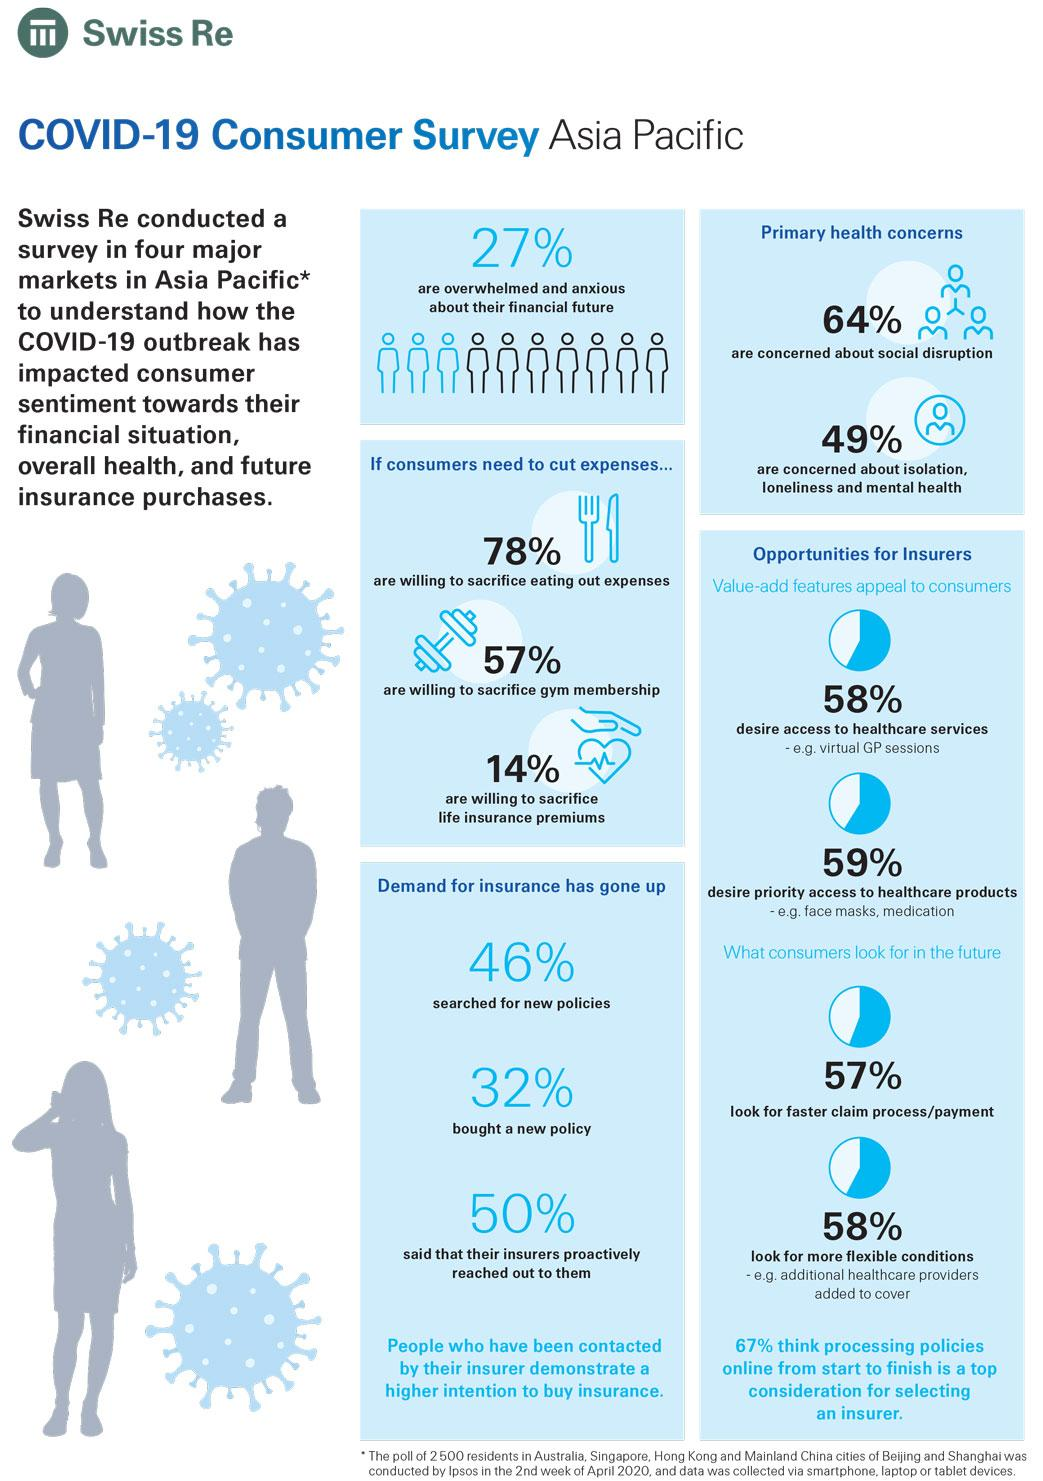Give some essential details in this illustration. According to the survey conducted in the Asia Pacific region, 36% of consumers are not concerned about social disruption. According to a survey conducted in the Asia Pacific region, 46% of consumers searched for new insurance policies. According to a recent survey conducted in the Asia Pacific region, 86% of consumers are unwilling to sacrifice life insurance premiums if they need to cut down on expenses. According to the survey conducted in the Asia Pacific region, 32% of consumers purchased a new policy. According to a survey conducted in the Asia Pacific region, 57% of consumers are willing to sacrifice their gym membership if they need to cut down on expenses. 